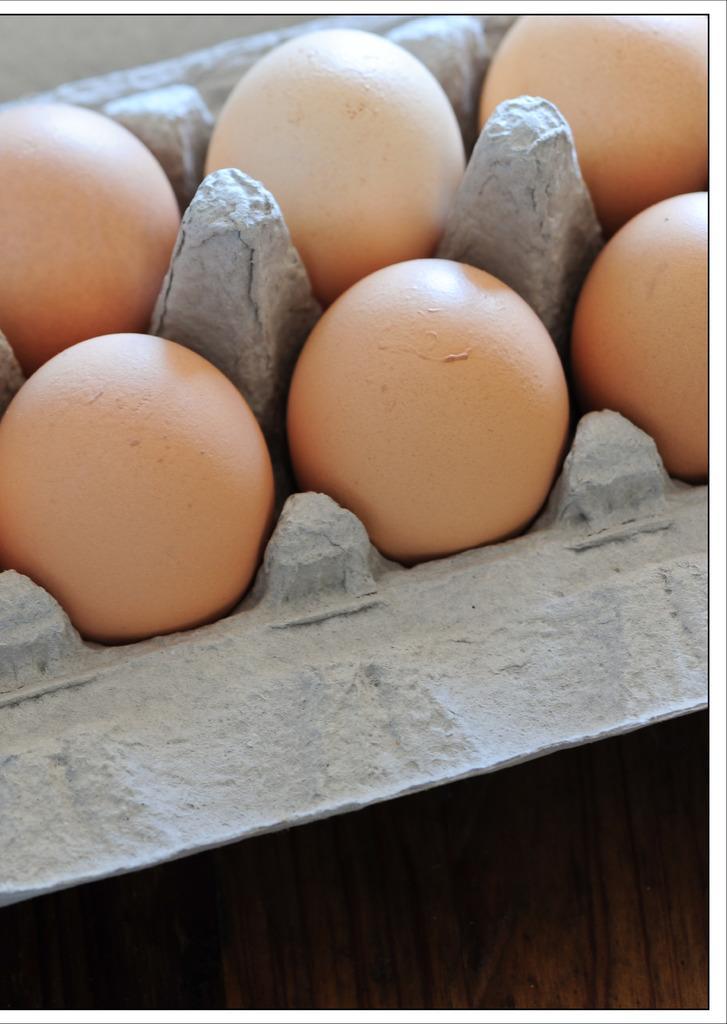Could you give a brief overview of what you see in this image? In this picture I can see eggs in the tray. 